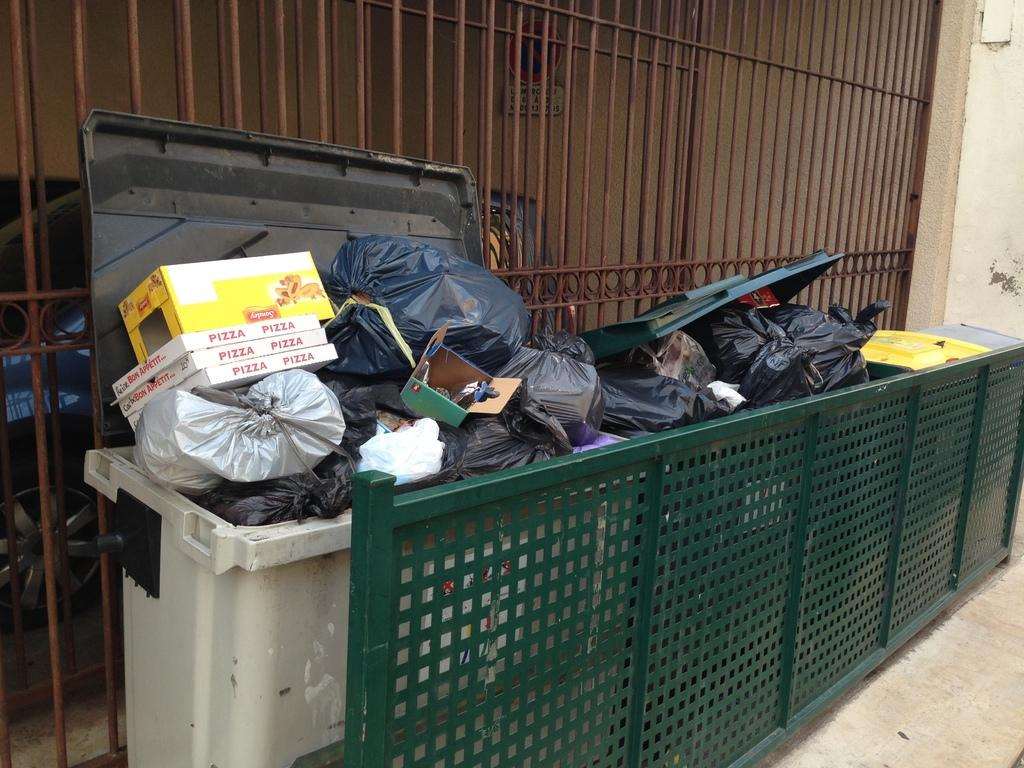Provide a one-sentence caption for the provided image. Three pizza boxes and a yellow box with the word Sondey on it all sit in a dumpster. 